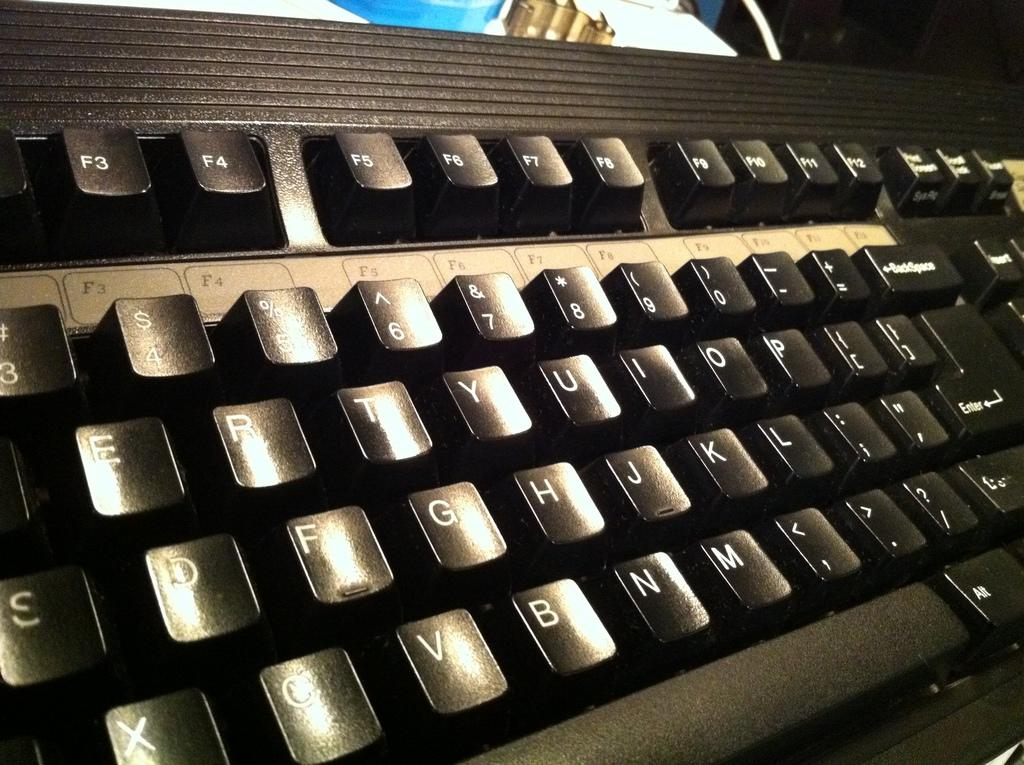<image>
Create a compact narrative representing the image presented. Many of the keys of a keyboard are visible including the G,H, and J. 